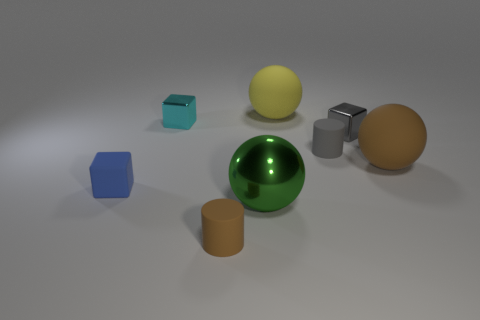How many large balls have the same color as the large metal thing?
Keep it short and to the point. 0. What number of things are small rubber cylinders that are to the right of the large yellow matte thing or small cubes that are to the right of the small rubber block?
Offer a terse response. 3. There is a large object that is behind the cyan cube; how many tiny shiny things are left of it?
Offer a terse response. 1. There is another small cylinder that is made of the same material as the gray cylinder; what is its color?
Give a very brief answer. Brown. Are there any yellow spheres of the same size as the gray shiny thing?
Offer a very short reply. No. There is a green shiny object that is the same size as the brown matte ball; what is its shape?
Provide a succinct answer. Sphere. Are there any tiny yellow objects of the same shape as the cyan object?
Your answer should be very brief. No. Are the brown cylinder and the big object in front of the small blue matte thing made of the same material?
Give a very brief answer. No. Is there a cube of the same color as the big metal ball?
Provide a succinct answer. No. What number of other objects are the same material as the big brown object?
Give a very brief answer. 4. 